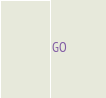Convert code to text. <code><loc_0><loc_0><loc_500><loc_500><_SQL_>GO</code> 